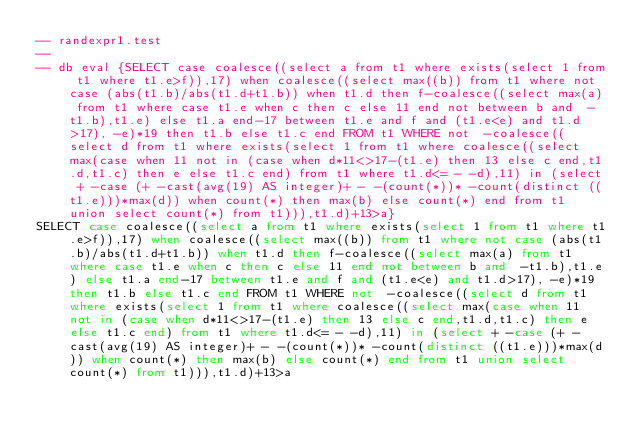Convert code to text. <code><loc_0><loc_0><loc_500><loc_500><_SQL_>-- randexpr1.test
-- 
-- db eval {SELECT case coalesce((select a from t1 where exists(select 1 from t1 where t1.e>f)),17) when coalesce((select max((b)) from t1 where not case (abs(t1.b)/abs(t1.d+t1.b)) when t1.d then f-coalesce((select max(a) from t1 where case t1.e when c then c else 11 end not between b and  -t1.b),t1.e) else t1.a end-17 between t1.e and f and (t1.e<e) and t1.d>17), -e)*19 then t1.b else t1.c end FROM t1 WHERE not  -coalesce((select d from t1 where exists(select 1 from t1 where coalesce((select max(case when 11 not in (case when d*11<>17-(t1.e) then 13 else c end,t1.d,t1.c) then e else t1.c end) from t1 where t1.d<= - -d),11) in (select + -case (+ -cast(avg(19) AS integer)+ - -(count(*))* -count(distinct ((t1.e)))*max(d)) when count(*) then max(b) else count(*) end from t1 union select count(*) from t1))),t1.d)+13>a}
SELECT case coalesce((select a from t1 where exists(select 1 from t1 where t1.e>f)),17) when coalesce((select max((b)) from t1 where not case (abs(t1.b)/abs(t1.d+t1.b)) when t1.d then f-coalesce((select max(a) from t1 where case t1.e when c then c else 11 end not between b and  -t1.b),t1.e) else t1.a end-17 between t1.e and f and (t1.e<e) and t1.d>17), -e)*19 then t1.b else t1.c end FROM t1 WHERE not  -coalesce((select d from t1 where exists(select 1 from t1 where coalesce((select max(case when 11 not in (case when d*11<>17-(t1.e) then 13 else c end,t1.d,t1.c) then e else t1.c end) from t1 where t1.d<= - -d),11) in (select + -case (+ -cast(avg(19) AS integer)+ - -(count(*))* -count(distinct ((t1.e)))*max(d)) when count(*) then max(b) else count(*) end from t1 union select count(*) from t1))),t1.d)+13>a</code> 